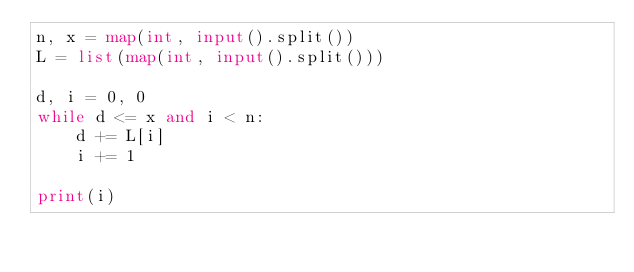Convert code to text. <code><loc_0><loc_0><loc_500><loc_500><_Python_>n, x = map(int, input().split())
L = list(map(int, input().split()))

d, i = 0, 0
while d <= x and i < n:
    d += L[i]
    i += 1

print(i)</code> 